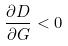Convert formula to latex. <formula><loc_0><loc_0><loc_500><loc_500>\frac { \partial D } { \partial G } < 0</formula> 